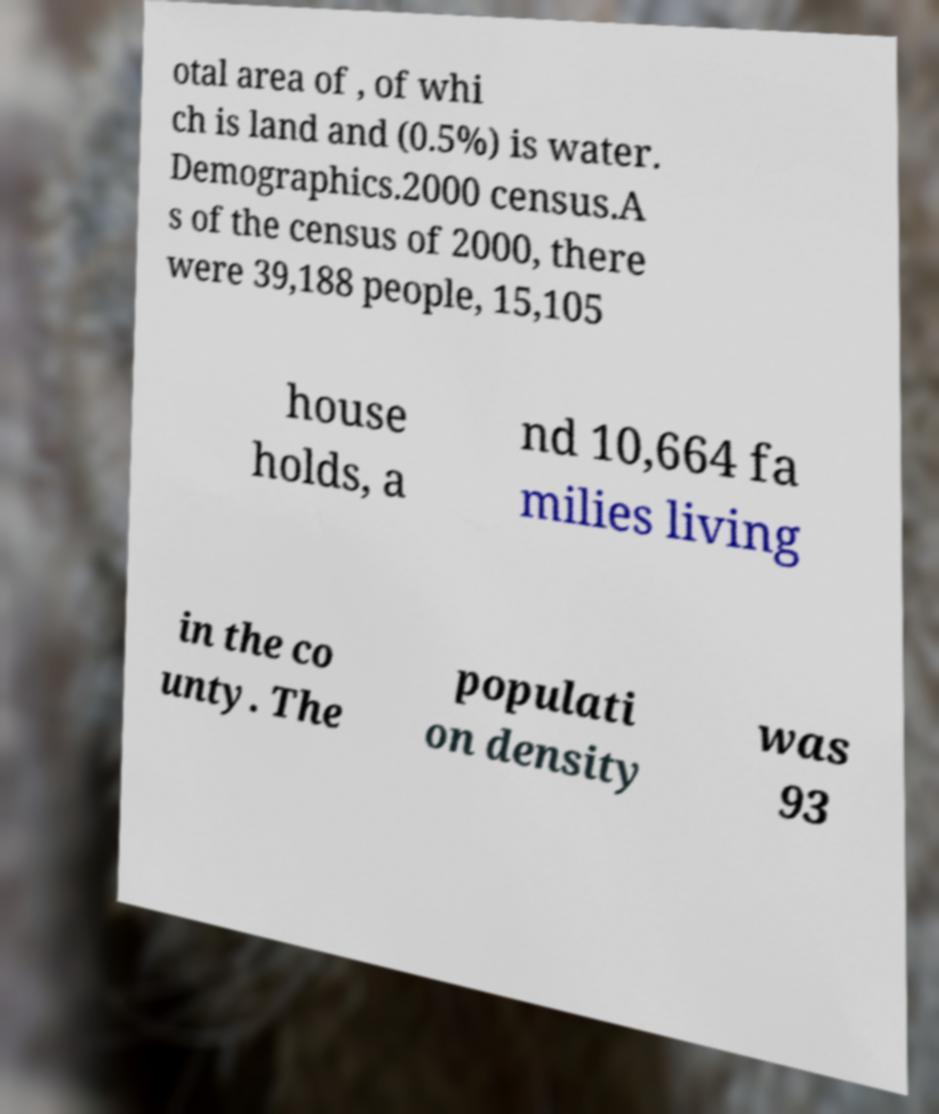There's text embedded in this image that I need extracted. Can you transcribe it verbatim? otal area of , of whi ch is land and (0.5%) is water. Demographics.2000 census.A s of the census of 2000, there were 39,188 people, 15,105 house holds, a nd 10,664 fa milies living in the co unty. The populati on density was 93 